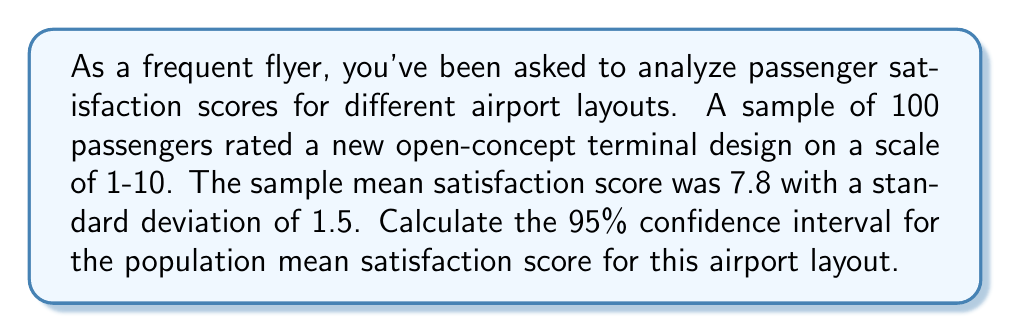Teach me how to tackle this problem. To calculate the confidence interval, we'll follow these steps:

1) The formula for the confidence interval is:

   $$\bar{x} \pm t_{\alpha/2} \cdot \frac{s}{\sqrt{n}}$$

   where $\bar{x}$ is the sample mean, $s$ is the sample standard deviation, $n$ is the sample size, and $t_{\alpha/2}$ is the t-value for a 95% confidence level with $n-1$ degrees of freedom.

2) We know:
   $\bar{x} = 7.8$
   $s = 1.5$
   $n = 100$
   Confidence level = 95%

3) For a 95% confidence level with 99 degrees of freedom (100 - 1), the t-value is approximately 1.984 (from t-distribution table).

4) Now, let's substitute these values into our formula:

   $$7.8 \pm 1.984 \cdot \frac{1.5}{\sqrt{100}}$$

5) Simplify:
   $$7.8 \pm 1.984 \cdot \frac{1.5}{10} = 7.8 \pm 1.984 \cdot 0.15 = 7.8 \pm 0.2976$$

6) Calculate the interval:
   Lower bound: $7.8 - 0.2976 = 7.5024$
   Upper bound: $7.8 + 0.2976 = 8.0976$

7) Round to two decimal places for practical interpretation.
Answer: (7.50, 8.10) 